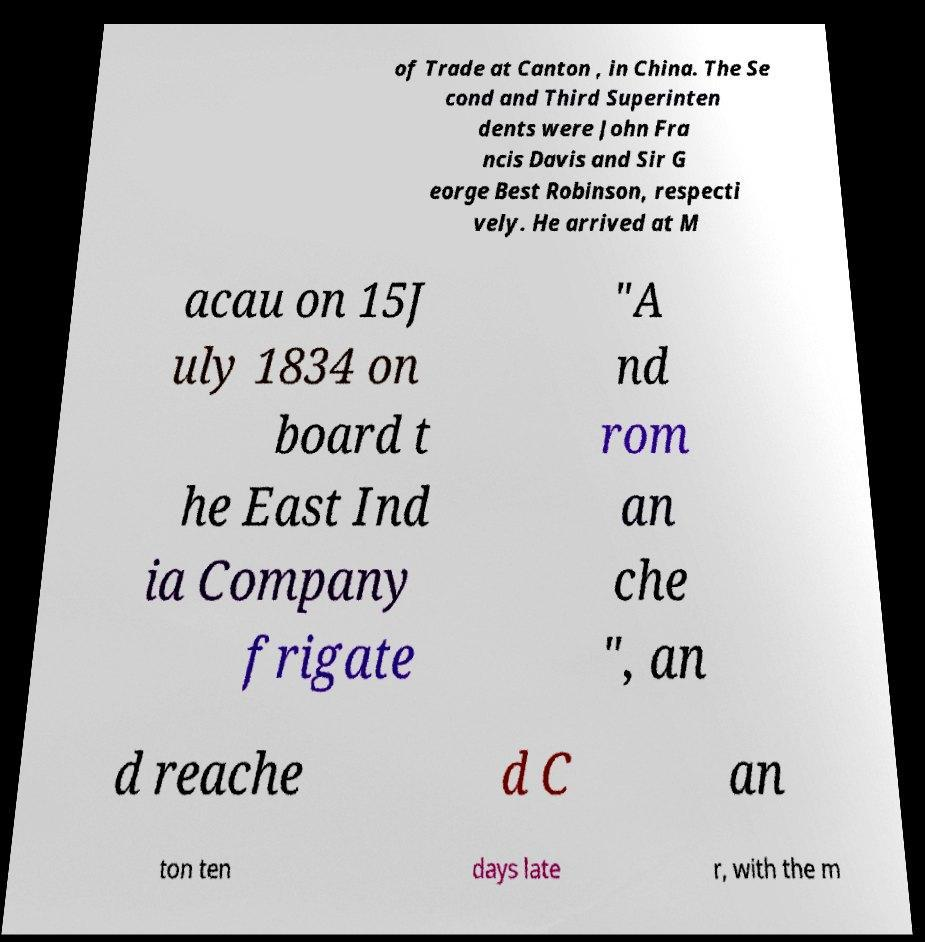For documentation purposes, I need the text within this image transcribed. Could you provide that? of Trade at Canton , in China. The Se cond and Third Superinten dents were John Fra ncis Davis and Sir G eorge Best Robinson, respecti vely. He arrived at M acau on 15J uly 1834 on board t he East Ind ia Company frigate "A nd rom an che ", an d reache d C an ton ten days late r, with the m 